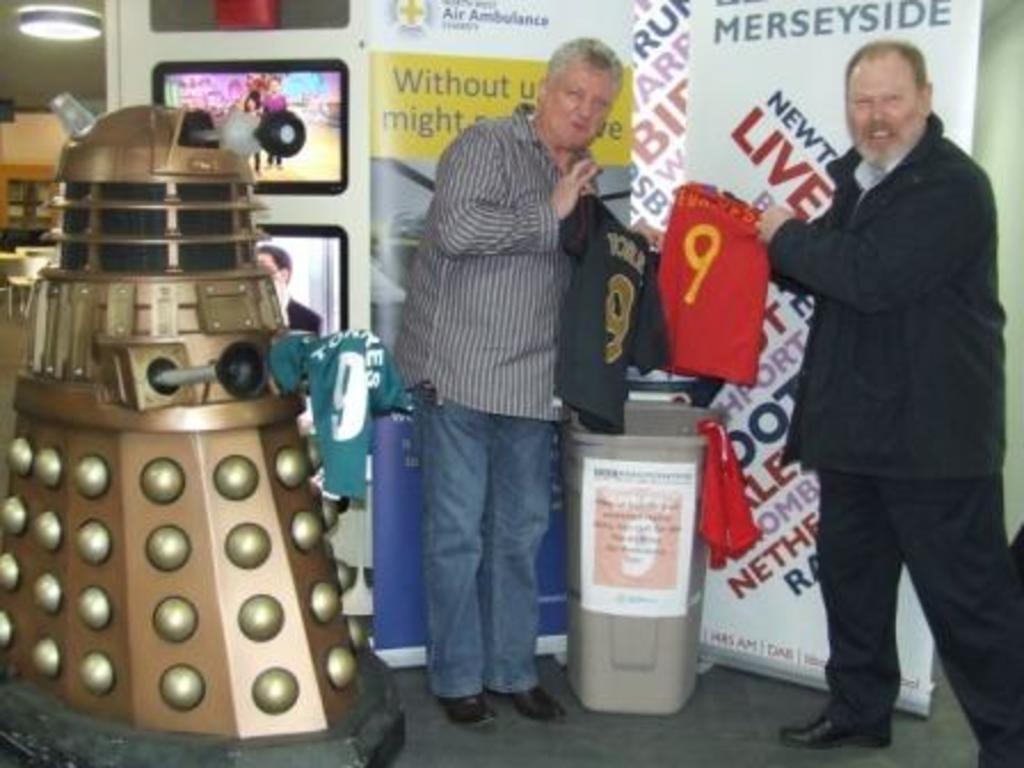Could you give a brief overview of what you see in this image? On the left side of the picture there is a machine. On the right side of the picture there are two men, t-shirts and dustbin, behind them there are banners. In the background towards left there are televisions, chairs and light. 